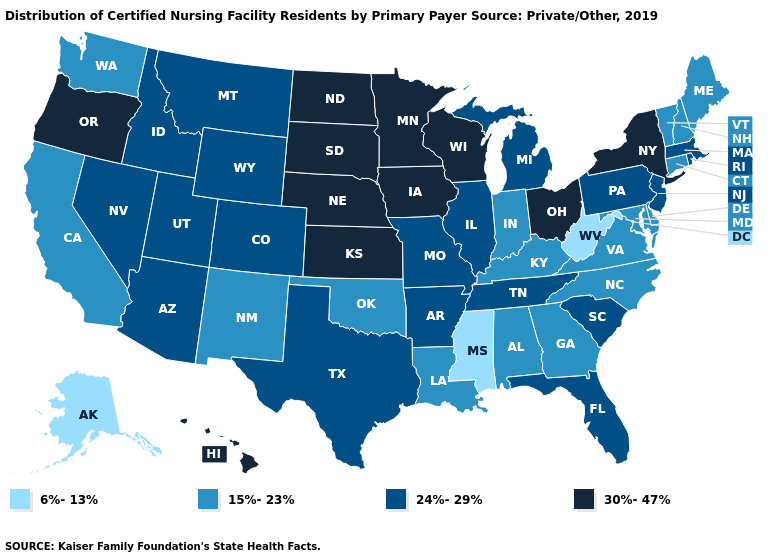Name the states that have a value in the range 15%-23%?
Short answer required. Alabama, California, Connecticut, Delaware, Georgia, Indiana, Kentucky, Louisiana, Maine, Maryland, New Hampshire, New Mexico, North Carolina, Oklahoma, Vermont, Virginia, Washington. Does Arkansas have a higher value than New York?
Answer briefly. No. Does Delaware have the same value as Georgia?
Answer briefly. Yes. How many symbols are there in the legend?
Short answer required. 4. What is the value of North Dakota?
Short answer required. 30%-47%. Is the legend a continuous bar?
Write a very short answer. No. What is the highest value in states that border Delaware?
Concise answer only. 24%-29%. What is the value of Illinois?
Write a very short answer. 24%-29%. What is the value of Michigan?
Answer briefly. 24%-29%. What is the value of Massachusetts?
Short answer required. 24%-29%. What is the lowest value in states that border Utah?
Be succinct. 15%-23%. Name the states that have a value in the range 15%-23%?
Concise answer only. Alabama, California, Connecticut, Delaware, Georgia, Indiana, Kentucky, Louisiana, Maine, Maryland, New Hampshire, New Mexico, North Carolina, Oklahoma, Vermont, Virginia, Washington. What is the value of Missouri?
Give a very brief answer. 24%-29%. What is the value of Illinois?
Concise answer only. 24%-29%. Which states hav the highest value in the South?
Keep it brief. Arkansas, Florida, South Carolina, Tennessee, Texas. 